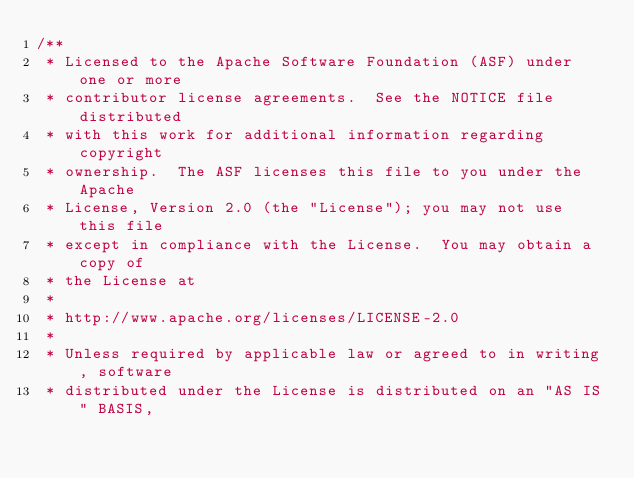Convert code to text. <code><loc_0><loc_0><loc_500><loc_500><_Java_>/**
 * Licensed to the Apache Software Foundation (ASF) under one or more
 * contributor license agreements.  See the NOTICE file distributed
 * with this work for additional information regarding copyright
 * ownership.  The ASF licenses this file to you under the Apache
 * License, Version 2.0 (the "License"); you may not use this file
 * except in compliance with the License.  You may obtain a copy of
 * the License at
 *
 * http://www.apache.org/licenses/LICENSE-2.0
 *
 * Unless required by applicable law or agreed to in writing, software
 * distributed under the License is distributed on an "AS IS" BASIS,</code> 